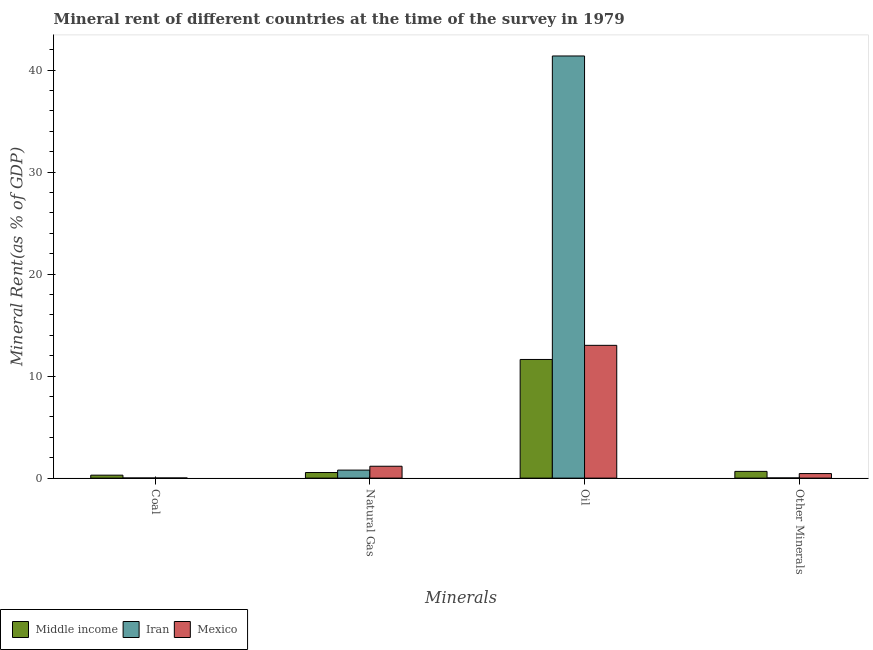How many different coloured bars are there?
Provide a succinct answer. 3. Are the number of bars per tick equal to the number of legend labels?
Provide a short and direct response. Yes. Are the number of bars on each tick of the X-axis equal?
Provide a succinct answer. Yes. How many bars are there on the 1st tick from the left?
Keep it short and to the point. 3. How many bars are there on the 2nd tick from the right?
Your response must be concise. 3. What is the label of the 2nd group of bars from the left?
Your response must be concise. Natural Gas. What is the natural gas rent in Mexico?
Provide a succinct answer. 1.16. Across all countries, what is the maximum  rent of other minerals?
Make the answer very short. 0.66. Across all countries, what is the minimum oil rent?
Your answer should be very brief. 11.63. In which country was the oil rent maximum?
Provide a short and direct response. Iran. In which country was the natural gas rent minimum?
Your answer should be compact. Middle income. What is the total natural gas rent in the graph?
Make the answer very short. 2.5. What is the difference between the  rent of other minerals in Mexico and that in Middle income?
Provide a short and direct response. -0.21. What is the difference between the oil rent in Mexico and the natural gas rent in Middle income?
Your answer should be very brief. 12.47. What is the average oil rent per country?
Ensure brevity in your answer.  22.01. What is the difference between the natural gas rent and oil rent in Middle income?
Your answer should be very brief. -11.08. In how many countries, is the  rent of other minerals greater than 26 %?
Provide a short and direct response. 0. What is the ratio of the coal rent in Mexico to that in Middle income?
Provide a short and direct response. 0.05. Is the  rent of other minerals in Iran less than that in Middle income?
Your answer should be compact. Yes. What is the difference between the highest and the second highest oil rent?
Your response must be concise. 28.37. What is the difference between the highest and the lowest natural gas rent?
Offer a terse response. 0.62. Is the sum of the  rent of other minerals in Iran and Middle income greater than the maximum oil rent across all countries?
Ensure brevity in your answer.  No. What does the 2nd bar from the left in Coal represents?
Give a very brief answer. Iran. How many bars are there?
Your answer should be very brief. 12. Are all the bars in the graph horizontal?
Your answer should be compact. No. How many countries are there in the graph?
Your answer should be compact. 3. Are the values on the major ticks of Y-axis written in scientific E-notation?
Give a very brief answer. No. How are the legend labels stacked?
Give a very brief answer. Horizontal. What is the title of the graph?
Give a very brief answer. Mineral rent of different countries at the time of the survey in 1979. Does "Rwanda" appear as one of the legend labels in the graph?
Your answer should be compact. No. What is the label or title of the X-axis?
Offer a very short reply. Minerals. What is the label or title of the Y-axis?
Provide a succinct answer. Mineral Rent(as % of GDP). What is the Mineral Rent(as % of GDP) in Middle income in Coal?
Your answer should be compact. 0.29. What is the Mineral Rent(as % of GDP) of Iran in Coal?
Keep it short and to the point. 0.01. What is the Mineral Rent(as % of GDP) in Mexico in Coal?
Give a very brief answer. 0.01. What is the Mineral Rent(as % of GDP) of Middle income in Natural Gas?
Keep it short and to the point. 0.55. What is the Mineral Rent(as % of GDP) of Iran in Natural Gas?
Provide a short and direct response. 0.79. What is the Mineral Rent(as % of GDP) in Mexico in Natural Gas?
Give a very brief answer. 1.16. What is the Mineral Rent(as % of GDP) of Middle income in Oil?
Keep it short and to the point. 11.63. What is the Mineral Rent(as % of GDP) in Iran in Oil?
Your answer should be very brief. 41.38. What is the Mineral Rent(as % of GDP) of Mexico in Oil?
Give a very brief answer. 13.02. What is the Mineral Rent(as % of GDP) of Middle income in Other Minerals?
Provide a succinct answer. 0.66. What is the Mineral Rent(as % of GDP) of Iran in Other Minerals?
Offer a very short reply. 0.02. What is the Mineral Rent(as % of GDP) of Mexico in Other Minerals?
Provide a short and direct response. 0.45. Across all Minerals, what is the maximum Mineral Rent(as % of GDP) in Middle income?
Give a very brief answer. 11.63. Across all Minerals, what is the maximum Mineral Rent(as % of GDP) in Iran?
Your response must be concise. 41.38. Across all Minerals, what is the maximum Mineral Rent(as % of GDP) of Mexico?
Your answer should be compact. 13.02. Across all Minerals, what is the minimum Mineral Rent(as % of GDP) in Middle income?
Keep it short and to the point. 0.29. Across all Minerals, what is the minimum Mineral Rent(as % of GDP) in Iran?
Provide a short and direct response. 0.01. Across all Minerals, what is the minimum Mineral Rent(as % of GDP) of Mexico?
Your answer should be very brief. 0.01. What is the total Mineral Rent(as % of GDP) of Middle income in the graph?
Provide a succinct answer. 13.13. What is the total Mineral Rent(as % of GDP) in Iran in the graph?
Your response must be concise. 42.2. What is the total Mineral Rent(as % of GDP) in Mexico in the graph?
Your response must be concise. 14.64. What is the difference between the Mineral Rent(as % of GDP) in Middle income in Coal and that in Natural Gas?
Offer a very short reply. -0.26. What is the difference between the Mineral Rent(as % of GDP) in Iran in Coal and that in Natural Gas?
Ensure brevity in your answer.  -0.77. What is the difference between the Mineral Rent(as % of GDP) of Mexico in Coal and that in Natural Gas?
Your answer should be very brief. -1.15. What is the difference between the Mineral Rent(as % of GDP) in Middle income in Coal and that in Oil?
Offer a terse response. -11.34. What is the difference between the Mineral Rent(as % of GDP) in Iran in Coal and that in Oil?
Provide a succinct answer. -41.37. What is the difference between the Mineral Rent(as % of GDP) in Mexico in Coal and that in Oil?
Offer a very short reply. -13. What is the difference between the Mineral Rent(as % of GDP) of Middle income in Coal and that in Other Minerals?
Make the answer very short. -0.37. What is the difference between the Mineral Rent(as % of GDP) of Iran in Coal and that in Other Minerals?
Your answer should be very brief. -0.01. What is the difference between the Mineral Rent(as % of GDP) of Mexico in Coal and that in Other Minerals?
Your answer should be compact. -0.43. What is the difference between the Mineral Rent(as % of GDP) in Middle income in Natural Gas and that in Oil?
Your answer should be compact. -11.08. What is the difference between the Mineral Rent(as % of GDP) in Iran in Natural Gas and that in Oil?
Keep it short and to the point. -40.6. What is the difference between the Mineral Rent(as % of GDP) of Mexico in Natural Gas and that in Oil?
Ensure brevity in your answer.  -11.85. What is the difference between the Mineral Rent(as % of GDP) of Middle income in Natural Gas and that in Other Minerals?
Offer a very short reply. -0.11. What is the difference between the Mineral Rent(as % of GDP) in Iran in Natural Gas and that in Other Minerals?
Give a very brief answer. 0.77. What is the difference between the Mineral Rent(as % of GDP) in Mexico in Natural Gas and that in Other Minerals?
Offer a very short reply. 0.72. What is the difference between the Mineral Rent(as % of GDP) of Middle income in Oil and that in Other Minerals?
Your answer should be very brief. 10.97. What is the difference between the Mineral Rent(as % of GDP) of Iran in Oil and that in Other Minerals?
Keep it short and to the point. 41.37. What is the difference between the Mineral Rent(as % of GDP) of Mexico in Oil and that in Other Minerals?
Make the answer very short. 12.57. What is the difference between the Mineral Rent(as % of GDP) of Middle income in Coal and the Mineral Rent(as % of GDP) of Iran in Natural Gas?
Offer a terse response. -0.5. What is the difference between the Mineral Rent(as % of GDP) of Middle income in Coal and the Mineral Rent(as % of GDP) of Mexico in Natural Gas?
Provide a succinct answer. -0.88. What is the difference between the Mineral Rent(as % of GDP) in Iran in Coal and the Mineral Rent(as % of GDP) in Mexico in Natural Gas?
Offer a terse response. -1.15. What is the difference between the Mineral Rent(as % of GDP) of Middle income in Coal and the Mineral Rent(as % of GDP) of Iran in Oil?
Make the answer very short. -41.1. What is the difference between the Mineral Rent(as % of GDP) in Middle income in Coal and the Mineral Rent(as % of GDP) in Mexico in Oil?
Your answer should be very brief. -12.73. What is the difference between the Mineral Rent(as % of GDP) in Iran in Coal and the Mineral Rent(as % of GDP) in Mexico in Oil?
Ensure brevity in your answer.  -13. What is the difference between the Mineral Rent(as % of GDP) in Middle income in Coal and the Mineral Rent(as % of GDP) in Iran in Other Minerals?
Make the answer very short. 0.27. What is the difference between the Mineral Rent(as % of GDP) in Middle income in Coal and the Mineral Rent(as % of GDP) in Mexico in Other Minerals?
Your answer should be very brief. -0.16. What is the difference between the Mineral Rent(as % of GDP) of Iran in Coal and the Mineral Rent(as % of GDP) of Mexico in Other Minerals?
Provide a short and direct response. -0.43. What is the difference between the Mineral Rent(as % of GDP) in Middle income in Natural Gas and the Mineral Rent(as % of GDP) in Iran in Oil?
Keep it short and to the point. -40.84. What is the difference between the Mineral Rent(as % of GDP) of Middle income in Natural Gas and the Mineral Rent(as % of GDP) of Mexico in Oil?
Ensure brevity in your answer.  -12.47. What is the difference between the Mineral Rent(as % of GDP) of Iran in Natural Gas and the Mineral Rent(as % of GDP) of Mexico in Oil?
Provide a short and direct response. -12.23. What is the difference between the Mineral Rent(as % of GDP) of Middle income in Natural Gas and the Mineral Rent(as % of GDP) of Iran in Other Minerals?
Your response must be concise. 0.53. What is the difference between the Mineral Rent(as % of GDP) in Middle income in Natural Gas and the Mineral Rent(as % of GDP) in Mexico in Other Minerals?
Your response must be concise. 0.1. What is the difference between the Mineral Rent(as % of GDP) in Iran in Natural Gas and the Mineral Rent(as % of GDP) in Mexico in Other Minerals?
Make the answer very short. 0.34. What is the difference between the Mineral Rent(as % of GDP) of Middle income in Oil and the Mineral Rent(as % of GDP) of Iran in Other Minerals?
Offer a terse response. 11.61. What is the difference between the Mineral Rent(as % of GDP) of Middle income in Oil and the Mineral Rent(as % of GDP) of Mexico in Other Minerals?
Provide a succinct answer. 11.19. What is the difference between the Mineral Rent(as % of GDP) of Iran in Oil and the Mineral Rent(as % of GDP) of Mexico in Other Minerals?
Your answer should be compact. 40.94. What is the average Mineral Rent(as % of GDP) in Middle income per Minerals?
Provide a succinct answer. 3.28. What is the average Mineral Rent(as % of GDP) of Iran per Minerals?
Offer a terse response. 10.55. What is the average Mineral Rent(as % of GDP) in Mexico per Minerals?
Your answer should be compact. 3.66. What is the difference between the Mineral Rent(as % of GDP) of Middle income and Mineral Rent(as % of GDP) of Iran in Coal?
Keep it short and to the point. 0.28. What is the difference between the Mineral Rent(as % of GDP) in Middle income and Mineral Rent(as % of GDP) in Mexico in Coal?
Your answer should be compact. 0.28. What is the difference between the Mineral Rent(as % of GDP) of Iran and Mineral Rent(as % of GDP) of Mexico in Coal?
Offer a very short reply. -0. What is the difference between the Mineral Rent(as % of GDP) in Middle income and Mineral Rent(as % of GDP) in Iran in Natural Gas?
Keep it short and to the point. -0.24. What is the difference between the Mineral Rent(as % of GDP) in Middle income and Mineral Rent(as % of GDP) in Mexico in Natural Gas?
Give a very brief answer. -0.62. What is the difference between the Mineral Rent(as % of GDP) of Iran and Mineral Rent(as % of GDP) of Mexico in Natural Gas?
Your answer should be compact. -0.38. What is the difference between the Mineral Rent(as % of GDP) of Middle income and Mineral Rent(as % of GDP) of Iran in Oil?
Provide a short and direct response. -29.75. What is the difference between the Mineral Rent(as % of GDP) of Middle income and Mineral Rent(as % of GDP) of Mexico in Oil?
Keep it short and to the point. -1.38. What is the difference between the Mineral Rent(as % of GDP) in Iran and Mineral Rent(as % of GDP) in Mexico in Oil?
Provide a short and direct response. 28.37. What is the difference between the Mineral Rent(as % of GDP) in Middle income and Mineral Rent(as % of GDP) in Iran in Other Minerals?
Give a very brief answer. 0.64. What is the difference between the Mineral Rent(as % of GDP) in Middle income and Mineral Rent(as % of GDP) in Mexico in Other Minerals?
Keep it short and to the point. 0.21. What is the difference between the Mineral Rent(as % of GDP) in Iran and Mineral Rent(as % of GDP) in Mexico in Other Minerals?
Offer a terse response. -0.43. What is the ratio of the Mineral Rent(as % of GDP) in Middle income in Coal to that in Natural Gas?
Make the answer very short. 0.53. What is the ratio of the Mineral Rent(as % of GDP) in Iran in Coal to that in Natural Gas?
Keep it short and to the point. 0.02. What is the ratio of the Mineral Rent(as % of GDP) of Mexico in Coal to that in Natural Gas?
Offer a very short reply. 0.01. What is the ratio of the Mineral Rent(as % of GDP) in Middle income in Coal to that in Oil?
Your answer should be compact. 0.02. What is the ratio of the Mineral Rent(as % of GDP) of Iran in Coal to that in Oil?
Give a very brief answer. 0. What is the ratio of the Mineral Rent(as % of GDP) in Mexico in Coal to that in Oil?
Your answer should be very brief. 0. What is the ratio of the Mineral Rent(as % of GDP) of Middle income in Coal to that in Other Minerals?
Give a very brief answer. 0.44. What is the ratio of the Mineral Rent(as % of GDP) in Iran in Coal to that in Other Minerals?
Make the answer very short. 0.66. What is the ratio of the Mineral Rent(as % of GDP) of Mexico in Coal to that in Other Minerals?
Offer a very short reply. 0.03. What is the ratio of the Mineral Rent(as % of GDP) in Middle income in Natural Gas to that in Oil?
Offer a terse response. 0.05. What is the ratio of the Mineral Rent(as % of GDP) of Iran in Natural Gas to that in Oil?
Your answer should be very brief. 0.02. What is the ratio of the Mineral Rent(as % of GDP) of Mexico in Natural Gas to that in Oil?
Ensure brevity in your answer.  0.09. What is the ratio of the Mineral Rent(as % of GDP) of Middle income in Natural Gas to that in Other Minerals?
Make the answer very short. 0.83. What is the ratio of the Mineral Rent(as % of GDP) of Iran in Natural Gas to that in Other Minerals?
Ensure brevity in your answer.  41.9. What is the ratio of the Mineral Rent(as % of GDP) of Mexico in Natural Gas to that in Other Minerals?
Make the answer very short. 2.61. What is the ratio of the Mineral Rent(as % of GDP) in Middle income in Oil to that in Other Minerals?
Your response must be concise. 17.63. What is the ratio of the Mineral Rent(as % of GDP) of Iran in Oil to that in Other Minerals?
Ensure brevity in your answer.  2204.33. What is the ratio of the Mineral Rent(as % of GDP) of Mexico in Oil to that in Other Minerals?
Provide a succinct answer. 29.16. What is the difference between the highest and the second highest Mineral Rent(as % of GDP) of Middle income?
Offer a terse response. 10.97. What is the difference between the highest and the second highest Mineral Rent(as % of GDP) of Iran?
Your response must be concise. 40.6. What is the difference between the highest and the second highest Mineral Rent(as % of GDP) in Mexico?
Your answer should be compact. 11.85. What is the difference between the highest and the lowest Mineral Rent(as % of GDP) in Middle income?
Your response must be concise. 11.34. What is the difference between the highest and the lowest Mineral Rent(as % of GDP) of Iran?
Make the answer very short. 41.37. What is the difference between the highest and the lowest Mineral Rent(as % of GDP) in Mexico?
Offer a very short reply. 13. 